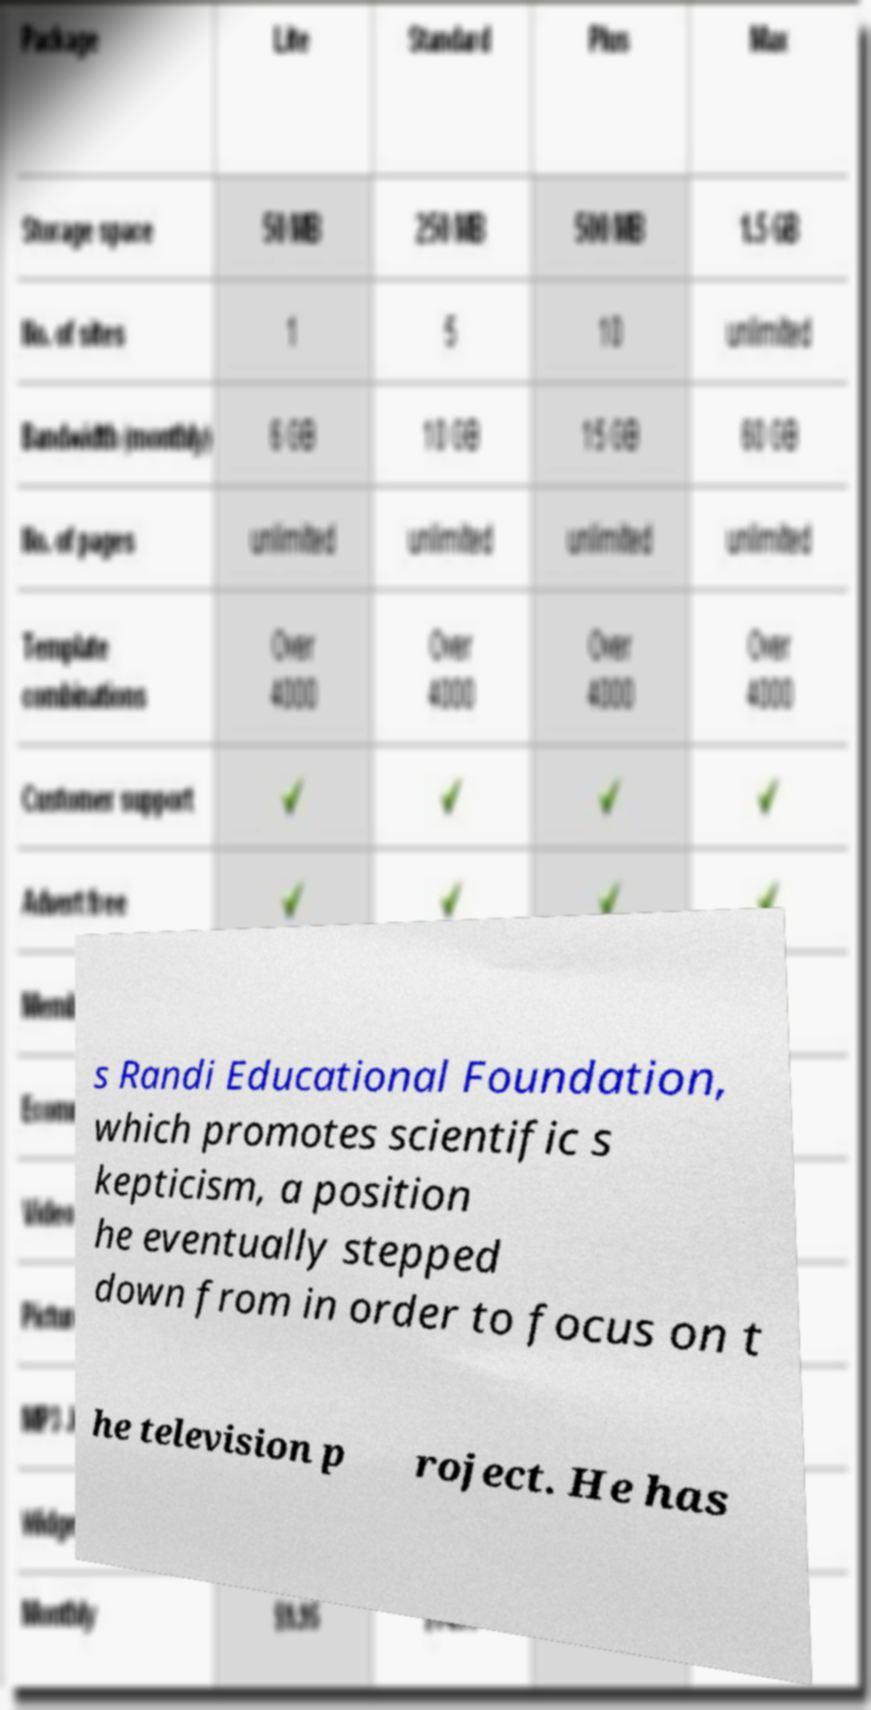For documentation purposes, I need the text within this image transcribed. Could you provide that? s Randi Educational Foundation, which promotes scientific s kepticism, a position he eventually stepped down from in order to focus on t he television p roject. He has 